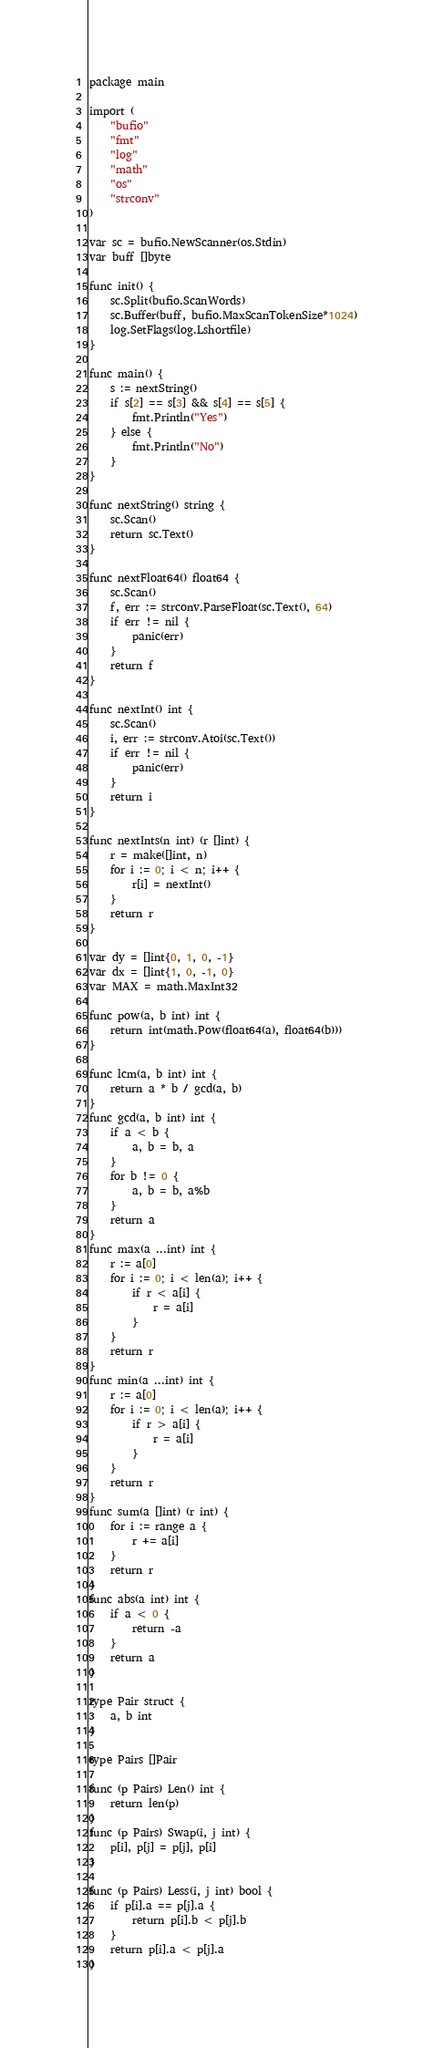<code> <loc_0><loc_0><loc_500><loc_500><_Go_>package main

import (
	"bufio"
	"fmt"
	"log"
	"math"
	"os"
	"strconv"
)

var sc = bufio.NewScanner(os.Stdin)
var buff []byte

func init() {
	sc.Split(bufio.ScanWords)
	sc.Buffer(buff, bufio.MaxScanTokenSize*1024)
	log.SetFlags(log.Lshortfile)
}

func main() {
	s := nextString()
	if s[2] == s[3] && s[4] == s[5] {
		fmt.Println("Yes")
	} else {
		fmt.Println("No")
	}
}

func nextString() string {
	sc.Scan()
	return sc.Text()
}

func nextFloat64() float64 {
	sc.Scan()
	f, err := strconv.ParseFloat(sc.Text(), 64)
	if err != nil {
		panic(err)
	}
	return f
}

func nextInt() int {
	sc.Scan()
	i, err := strconv.Atoi(sc.Text())
	if err != nil {
		panic(err)
	}
	return i
}

func nextInts(n int) (r []int) {
	r = make([]int, n)
	for i := 0; i < n; i++ {
		r[i] = nextInt()
	}
	return r
}

var dy = []int{0, 1, 0, -1}
var dx = []int{1, 0, -1, 0}
var MAX = math.MaxInt32

func pow(a, b int) int {
	return int(math.Pow(float64(a), float64(b)))
}

func lcm(a, b int) int {
	return a * b / gcd(a, b)
}
func gcd(a, b int) int {
	if a < b {
		a, b = b, a
	}
	for b != 0 {
		a, b = b, a%b
	}
	return a
}
func max(a ...int) int {
	r := a[0]
	for i := 0; i < len(a); i++ {
		if r < a[i] {
			r = a[i]
		}
	}
	return r
}
func min(a ...int) int {
	r := a[0]
	for i := 0; i < len(a); i++ {
		if r > a[i] {
			r = a[i]
		}
	}
	return r
}
func sum(a []int) (r int) {
	for i := range a {
		r += a[i]
	}
	return r
}
func abs(a int) int {
	if a < 0 {
		return -a
	}
	return a
}

type Pair struct {
	a, b int
}

type Pairs []Pair

func (p Pairs) Len() int {
	return len(p)
}
func (p Pairs) Swap(i, j int) {
	p[i], p[j] = p[j], p[i]
}

func (p Pairs) Less(i, j int) bool {
	if p[i].a == p[j].a {
		return p[i].b < p[j].b
	}
	return p[i].a < p[j].a
}
</code> 